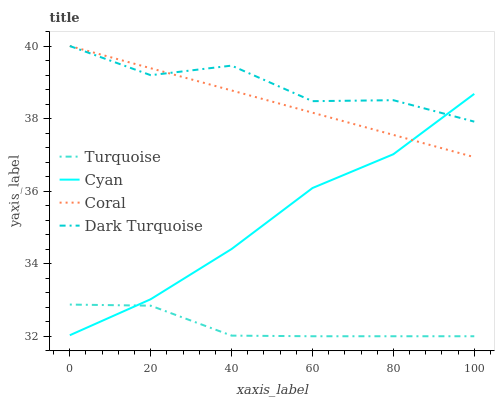Does Coral have the minimum area under the curve?
Answer yes or no. No. Does Coral have the maximum area under the curve?
Answer yes or no. No. Is Turquoise the smoothest?
Answer yes or no. No. Is Turquoise the roughest?
Answer yes or no. No. Does Coral have the lowest value?
Answer yes or no. No. Does Turquoise have the highest value?
Answer yes or no. No. Is Turquoise less than Dark Turquoise?
Answer yes or no. Yes. Is Dark Turquoise greater than Turquoise?
Answer yes or no. Yes. Does Turquoise intersect Dark Turquoise?
Answer yes or no. No. 